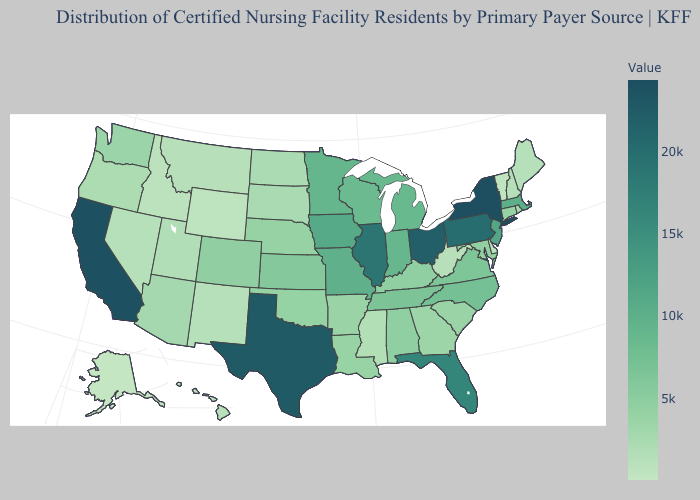Does Delaware have the lowest value in the South?
Give a very brief answer. Yes. Is the legend a continuous bar?
Keep it brief. Yes. Does North Dakota have a lower value than Wisconsin?
Keep it brief. Yes. Which states have the lowest value in the West?
Be succinct. Alaska. 